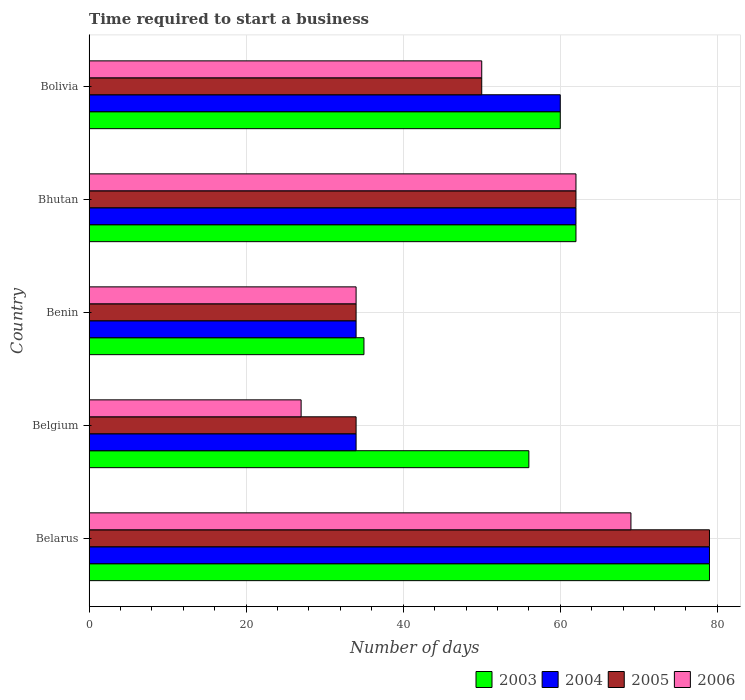How many groups of bars are there?
Ensure brevity in your answer.  5. Are the number of bars per tick equal to the number of legend labels?
Ensure brevity in your answer.  Yes. Are the number of bars on each tick of the Y-axis equal?
Your response must be concise. Yes. How many bars are there on the 1st tick from the top?
Your response must be concise. 4. How many bars are there on the 1st tick from the bottom?
Your answer should be compact. 4. What is the label of the 1st group of bars from the top?
Your response must be concise. Bolivia. In how many cases, is the number of bars for a given country not equal to the number of legend labels?
Make the answer very short. 0. In which country was the number of days required to start a business in 2003 maximum?
Your answer should be compact. Belarus. What is the total number of days required to start a business in 2006 in the graph?
Your answer should be compact. 242. What is the difference between the number of days required to start a business in 2005 in Bhutan and the number of days required to start a business in 2004 in Belgium?
Make the answer very short. 28. What is the average number of days required to start a business in 2004 per country?
Provide a short and direct response. 53.8. What is the difference between the number of days required to start a business in 2004 and number of days required to start a business in 2005 in Bhutan?
Keep it short and to the point. 0. In how many countries, is the number of days required to start a business in 2004 greater than 36 days?
Make the answer very short. 3. What is the ratio of the number of days required to start a business in 2003 in Belarus to that in Benin?
Provide a short and direct response. 2.26. Is the number of days required to start a business in 2006 in Belgium less than that in Benin?
Offer a very short reply. Yes. Is the difference between the number of days required to start a business in 2004 in Belarus and Benin greater than the difference between the number of days required to start a business in 2005 in Belarus and Benin?
Your response must be concise. No. What is the difference between the highest and the second highest number of days required to start a business in 2004?
Make the answer very short. 17. In how many countries, is the number of days required to start a business in 2006 greater than the average number of days required to start a business in 2006 taken over all countries?
Make the answer very short. 3. Is it the case that in every country, the sum of the number of days required to start a business in 2005 and number of days required to start a business in 2004 is greater than the number of days required to start a business in 2006?
Offer a very short reply. Yes. How many bars are there?
Your answer should be compact. 20. How many countries are there in the graph?
Your response must be concise. 5. What is the difference between two consecutive major ticks on the X-axis?
Your answer should be compact. 20. Are the values on the major ticks of X-axis written in scientific E-notation?
Offer a very short reply. No. Does the graph contain any zero values?
Ensure brevity in your answer.  No. Does the graph contain grids?
Offer a terse response. Yes. Where does the legend appear in the graph?
Your answer should be compact. Bottom right. How are the legend labels stacked?
Keep it short and to the point. Horizontal. What is the title of the graph?
Offer a terse response. Time required to start a business. What is the label or title of the X-axis?
Your answer should be very brief. Number of days. What is the label or title of the Y-axis?
Your answer should be compact. Country. What is the Number of days in 2003 in Belarus?
Provide a short and direct response. 79. What is the Number of days of 2004 in Belarus?
Give a very brief answer. 79. What is the Number of days in 2005 in Belarus?
Provide a short and direct response. 79. What is the Number of days of 2003 in Belgium?
Ensure brevity in your answer.  56. What is the Number of days in 2005 in Belgium?
Ensure brevity in your answer.  34. What is the Number of days of 2006 in Belgium?
Your answer should be compact. 27. What is the Number of days of 2003 in Benin?
Keep it short and to the point. 35. What is the Number of days of 2004 in Benin?
Your answer should be compact. 34. What is the Number of days in 2006 in Benin?
Provide a succinct answer. 34. What is the Number of days in 2003 in Bhutan?
Offer a terse response. 62. What is the Number of days in 2004 in Bhutan?
Your answer should be very brief. 62. What is the Number of days of 2005 in Bhutan?
Give a very brief answer. 62. What is the Number of days of 2006 in Bhutan?
Make the answer very short. 62. What is the Number of days in 2003 in Bolivia?
Make the answer very short. 60. What is the Number of days in 2004 in Bolivia?
Provide a short and direct response. 60. What is the Number of days of 2006 in Bolivia?
Your answer should be compact. 50. Across all countries, what is the maximum Number of days of 2003?
Provide a short and direct response. 79. Across all countries, what is the maximum Number of days of 2004?
Offer a terse response. 79. Across all countries, what is the maximum Number of days of 2005?
Keep it short and to the point. 79. Across all countries, what is the maximum Number of days in 2006?
Your answer should be very brief. 69. Across all countries, what is the minimum Number of days in 2004?
Your answer should be very brief. 34. What is the total Number of days in 2003 in the graph?
Your answer should be very brief. 292. What is the total Number of days of 2004 in the graph?
Provide a short and direct response. 269. What is the total Number of days in 2005 in the graph?
Your answer should be compact. 259. What is the total Number of days of 2006 in the graph?
Your response must be concise. 242. What is the difference between the Number of days of 2003 in Belarus and that in Belgium?
Provide a succinct answer. 23. What is the difference between the Number of days in 2005 in Belarus and that in Belgium?
Your answer should be compact. 45. What is the difference between the Number of days of 2006 in Belarus and that in Belgium?
Your answer should be compact. 42. What is the difference between the Number of days in 2003 in Belarus and that in Benin?
Your answer should be very brief. 44. What is the difference between the Number of days in 2004 in Belarus and that in Benin?
Provide a short and direct response. 45. What is the difference between the Number of days in 2003 in Belarus and that in Bhutan?
Offer a very short reply. 17. What is the difference between the Number of days in 2004 in Belarus and that in Bhutan?
Give a very brief answer. 17. What is the difference between the Number of days in 2003 in Belarus and that in Bolivia?
Your answer should be very brief. 19. What is the difference between the Number of days in 2003 in Belgium and that in Benin?
Offer a very short reply. 21. What is the difference between the Number of days of 2006 in Belgium and that in Bhutan?
Make the answer very short. -35. What is the difference between the Number of days in 2006 in Belgium and that in Bolivia?
Provide a succinct answer. -23. What is the difference between the Number of days of 2003 in Benin and that in Bhutan?
Provide a short and direct response. -27. What is the difference between the Number of days in 2004 in Benin and that in Bhutan?
Give a very brief answer. -28. What is the difference between the Number of days in 2005 in Benin and that in Bhutan?
Your answer should be compact. -28. What is the difference between the Number of days of 2006 in Benin and that in Bhutan?
Your answer should be compact. -28. What is the difference between the Number of days of 2006 in Bhutan and that in Bolivia?
Provide a succinct answer. 12. What is the difference between the Number of days in 2003 in Belarus and the Number of days in 2004 in Belgium?
Ensure brevity in your answer.  45. What is the difference between the Number of days of 2003 in Belarus and the Number of days of 2005 in Belgium?
Ensure brevity in your answer.  45. What is the difference between the Number of days of 2003 in Belarus and the Number of days of 2006 in Belgium?
Keep it short and to the point. 52. What is the difference between the Number of days of 2003 in Belarus and the Number of days of 2005 in Benin?
Provide a short and direct response. 45. What is the difference between the Number of days in 2004 in Belarus and the Number of days in 2005 in Benin?
Ensure brevity in your answer.  45. What is the difference between the Number of days in 2003 in Belarus and the Number of days in 2005 in Bhutan?
Provide a short and direct response. 17. What is the difference between the Number of days of 2004 in Belarus and the Number of days of 2006 in Bhutan?
Your answer should be compact. 17. What is the difference between the Number of days of 2003 in Belarus and the Number of days of 2005 in Bolivia?
Offer a very short reply. 29. What is the difference between the Number of days in 2003 in Belarus and the Number of days in 2006 in Bolivia?
Provide a succinct answer. 29. What is the difference between the Number of days of 2003 in Belgium and the Number of days of 2006 in Benin?
Your answer should be compact. 22. What is the difference between the Number of days of 2004 in Belgium and the Number of days of 2005 in Benin?
Your answer should be compact. 0. What is the difference between the Number of days in 2004 in Belgium and the Number of days in 2006 in Benin?
Provide a short and direct response. 0. What is the difference between the Number of days of 2005 in Belgium and the Number of days of 2006 in Benin?
Give a very brief answer. 0. What is the difference between the Number of days in 2003 in Belgium and the Number of days in 2006 in Bhutan?
Keep it short and to the point. -6. What is the difference between the Number of days in 2004 in Belgium and the Number of days in 2006 in Bhutan?
Provide a succinct answer. -28. What is the difference between the Number of days in 2005 in Belgium and the Number of days in 2006 in Bhutan?
Provide a short and direct response. -28. What is the difference between the Number of days of 2003 in Belgium and the Number of days of 2004 in Bolivia?
Keep it short and to the point. -4. What is the difference between the Number of days of 2003 in Benin and the Number of days of 2004 in Bhutan?
Your response must be concise. -27. What is the difference between the Number of days in 2003 in Benin and the Number of days in 2005 in Bhutan?
Provide a short and direct response. -27. What is the difference between the Number of days of 2004 in Benin and the Number of days of 2005 in Bhutan?
Offer a terse response. -28. What is the difference between the Number of days in 2005 in Benin and the Number of days in 2006 in Bhutan?
Provide a succinct answer. -28. What is the difference between the Number of days in 2003 in Benin and the Number of days in 2006 in Bolivia?
Your answer should be compact. -15. What is the difference between the Number of days in 2003 in Bhutan and the Number of days in 2004 in Bolivia?
Offer a very short reply. 2. What is the difference between the Number of days of 2003 in Bhutan and the Number of days of 2006 in Bolivia?
Your answer should be very brief. 12. What is the difference between the Number of days in 2004 in Bhutan and the Number of days in 2005 in Bolivia?
Give a very brief answer. 12. What is the difference between the Number of days of 2004 in Bhutan and the Number of days of 2006 in Bolivia?
Your response must be concise. 12. What is the average Number of days of 2003 per country?
Give a very brief answer. 58.4. What is the average Number of days in 2004 per country?
Keep it short and to the point. 53.8. What is the average Number of days in 2005 per country?
Offer a very short reply. 51.8. What is the average Number of days in 2006 per country?
Make the answer very short. 48.4. What is the difference between the Number of days in 2003 and Number of days in 2004 in Belarus?
Offer a very short reply. 0. What is the difference between the Number of days in 2003 and Number of days in 2006 in Belarus?
Provide a succinct answer. 10. What is the difference between the Number of days in 2004 and Number of days in 2006 in Belarus?
Offer a terse response. 10. What is the difference between the Number of days of 2003 and Number of days of 2004 in Belgium?
Your answer should be very brief. 22. What is the difference between the Number of days in 2003 and Number of days in 2005 in Belgium?
Your answer should be compact. 22. What is the difference between the Number of days of 2004 and Number of days of 2005 in Belgium?
Ensure brevity in your answer.  0. What is the difference between the Number of days in 2004 and Number of days in 2006 in Belgium?
Provide a short and direct response. 7. What is the difference between the Number of days of 2005 and Number of days of 2006 in Belgium?
Offer a terse response. 7. What is the difference between the Number of days in 2003 and Number of days in 2005 in Benin?
Keep it short and to the point. 1. What is the difference between the Number of days of 2003 and Number of days of 2006 in Benin?
Make the answer very short. 1. What is the difference between the Number of days in 2004 and Number of days in 2005 in Benin?
Give a very brief answer. 0. What is the difference between the Number of days of 2003 and Number of days of 2005 in Bhutan?
Give a very brief answer. 0. What is the difference between the Number of days in 2003 and Number of days in 2006 in Bhutan?
Your answer should be compact. 0. What is the difference between the Number of days in 2004 and Number of days in 2006 in Bhutan?
Make the answer very short. 0. What is the difference between the Number of days in 2003 and Number of days in 2004 in Bolivia?
Keep it short and to the point. 0. What is the difference between the Number of days in 2003 and Number of days in 2005 in Bolivia?
Make the answer very short. 10. What is the difference between the Number of days of 2003 and Number of days of 2006 in Bolivia?
Make the answer very short. 10. What is the difference between the Number of days in 2004 and Number of days in 2005 in Bolivia?
Keep it short and to the point. 10. What is the ratio of the Number of days of 2003 in Belarus to that in Belgium?
Ensure brevity in your answer.  1.41. What is the ratio of the Number of days of 2004 in Belarus to that in Belgium?
Give a very brief answer. 2.32. What is the ratio of the Number of days of 2005 in Belarus to that in Belgium?
Ensure brevity in your answer.  2.32. What is the ratio of the Number of days in 2006 in Belarus to that in Belgium?
Provide a succinct answer. 2.56. What is the ratio of the Number of days of 2003 in Belarus to that in Benin?
Your answer should be compact. 2.26. What is the ratio of the Number of days in 2004 in Belarus to that in Benin?
Your response must be concise. 2.32. What is the ratio of the Number of days of 2005 in Belarus to that in Benin?
Provide a succinct answer. 2.32. What is the ratio of the Number of days in 2006 in Belarus to that in Benin?
Your answer should be very brief. 2.03. What is the ratio of the Number of days of 2003 in Belarus to that in Bhutan?
Your response must be concise. 1.27. What is the ratio of the Number of days of 2004 in Belarus to that in Bhutan?
Your answer should be very brief. 1.27. What is the ratio of the Number of days in 2005 in Belarus to that in Bhutan?
Ensure brevity in your answer.  1.27. What is the ratio of the Number of days in 2006 in Belarus to that in Bhutan?
Give a very brief answer. 1.11. What is the ratio of the Number of days of 2003 in Belarus to that in Bolivia?
Provide a succinct answer. 1.32. What is the ratio of the Number of days in 2004 in Belarus to that in Bolivia?
Your answer should be very brief. 1.32. What is the ratio of the Number of days in 2005 in Belarus to that in Bolivia?
Your response must be concise. 1.58. What is the ratio of the Number of days of 2006 in Belarus to that in Bolivia?
Provide a succinct answer. 1.38. What is the ratio of the Number of days of 2006 in Belgium to that in Benin?
Give a very brief answer. 0.79. What is the ratio of the Number of days in 2003 in Belgium to that in Bhutan?
Your answer should be very brief. 0.9. What is the ratio of the Number of days in 2004 in Belgium to that in Bhutan?
Ensure brevity in your answer.  0.55. What is the ratio of the Number of days of 2005 in Belgium to that in Bhutan?
Your response must be concise. 0.55. What is the ratio of the Number of days of 2006 in Belgium to that in Bhutan?
Ensure brevity in your answer.  0.44. What is the ratio of the Number of days of 2004 in Belgium to that in Bolivia?
Offer a very short reply. 0.57. What is the ratio of the Number of days in 2005 in Belgium to that in Bolivia?
Ensure brevity in your answer.  0.68. What is the ratio of the Number of days in 2006 in Belgium to that in Bolivia?
Your response must be concise. 0.54. What is the ratio of the Number of days in 2003 in Benin to that in Bhutan?
Provide a succinct answer. 0.56. What is the ratio of the Number of days of 2004 in Benin to that in Bhutan?
Give a very brief answer. 0.55. What is the ratio of the Number of days of 2005 in Benin to that in Bhutan?
Provide a succinct answer. 0.55. What is the ratio of the Number of days in 2006 in Benin to that in Bhutan?
Offer a terse response. 0.55. What is the ratio of the Number of days in 2003 in Benin to that in Bolivia?
Make the answer very short. 0.58. What is the ratio of the Number of days of 2004 in Benin to that in Bolivia?
Make the answer very short. 0.57. What is the ratio of the Number of days of 2005 in Benin to that in Bolivia?
Provide a succinct answer. 0.68. What is the ratio of the Number of days in 2006 in Benin to that in Bolivia?
Offer a terse response. 0.68. What is the ratio of the Number of days in 2005 in Bhutan to that in Bolivia?
Give a very brief answer. 1.24. What is the ratio of the Number of days in 2006 in Bhutan to that in Bolivia?
Your answer should be very brief. 1.24. What is the difference between the highest and the second highest Number of days in 2004?
Ensure brevity in your answer.  17. What is the difference between the highest and the second highest Number of days in 2006?
Give a very brief answer. 7. What is the difference between the highest and the lowest Number of days in 2003?
Your answer should be very brief. 44. What is the difference between the highest and the lowest Number of days of 2005?
Offer a very short reply. 45. 